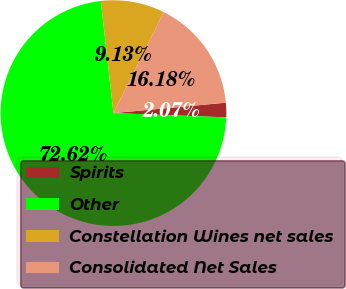Convert chart to OTSL. <chart><loc_0><loc_0><loc_500><loc_500><pie_chart><fcel>Spirits<fcel>Other<fcel>Constellation Wines net sales<fcel>Consolidated Net Sales<nl><fcel>2.07%<fcel>72.61%<fcel>9.13%<fcel>16.18%<nl></chart> 